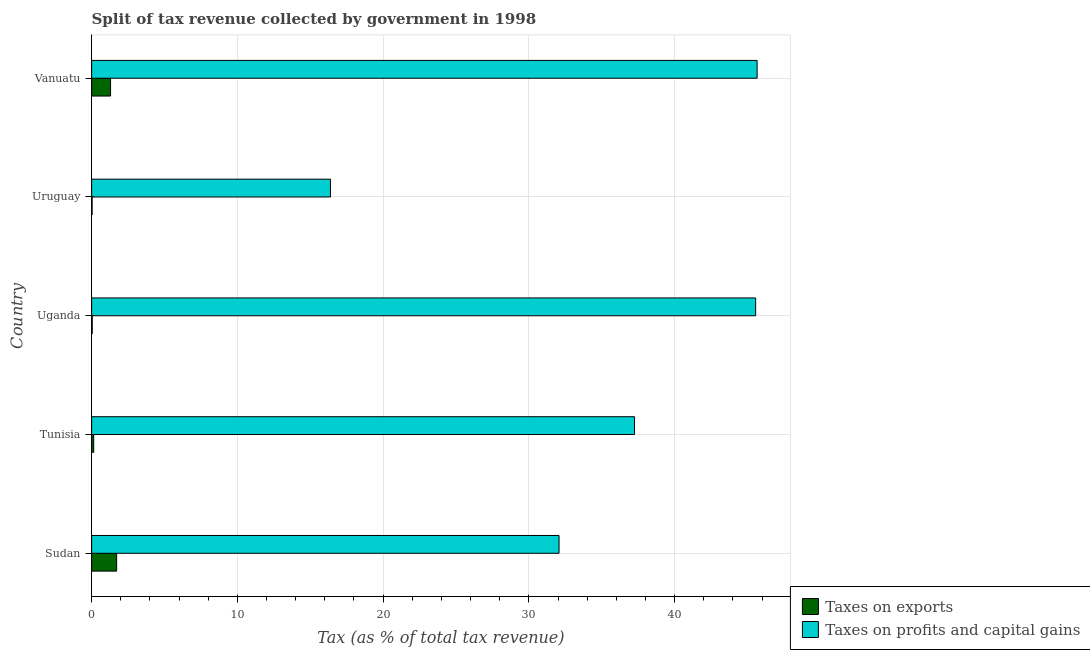How many different coloured bars are there?
Offer a terse response. 2. Are the number of bars per tick equal to the number of legend labels?
Ensure brevity in your answer.  Yes. Are the number of bars on each tick of the Y-axis equal?
Your answer should be compact. Yes. What is the label of the 2nd group of bars from the top?
Your response must be concise. Uruguay. What is the percentage of revenue obtained from taxes on exports in Uganda?
Provide a short and direct response. 0.04. Across all countries, what is the maximum percentage of revenue obtained from taxes on profits and capital gains?
Keep it short and to the point. 45.66. Across all countries, what is the minimum percentage of revenue obtained from taxes on profits and capital gains?
Ensure brevity in your answer.  16.39. In which country was the percentage of revenue obtained from taxes on exports maximum?
Make the answer very short. Sudan. In which country was the percentage of revenue obtained from taxes on exports minimum?
Ensure brevity in your answer.  Uruguay. What is the total percentage of revenue obtained from taxes on profits and capital gains in the graph?
Offer a terse response. 176.92. What is the difference between the percentage of revenue obtained from taxes on exports in Uganda and that in Uruguay?
Your answer should be compact. 0.01. What is the difference between the percentage of revenue obtained from taxes on exports in Uruguay and the percentage of revenue obtained from taxes on profits and capital gains in Tunisia?
Ensure brevity in your answer.  -37.22. What is the average percentage of revenue obtained from taxes on exports per country?
Make the answer very short. 0.65. What is the difference between the percentage of revenue obtained from taxes on profits and capital gains and percentage of revenue obtained from taxes on exports in Uganda?
Your response must be concise. 45.52. In how many countries, is the percentage of revenue obtained from taxes on exports greater than 14 %?
Your answer should be very brief. 0. What is the ratio of the percentage of revenue obtained from taxes on exports in Uganda to that in Vanuatu?
Ensure brevity in your answer.  0.03. Is the percentage of revenue obtained from taxes on exports in Sudan less than that in Uganda?
Keep it short and to the point. No. What is the difference between the highest and the second highest percentage of revenue obtained from taxes on exports?
Provide a succinct answer. 0.42. What is the difference between the highest and the lowest percentage of revenue obtained from taxes on profits and capital gains?
Make the answer very short. 29.27. What does the 2nd bar from the top in Uruguay represents?
Provide a short and direct response. Taxes on exports. What does the 2nd bar from the bottom in Tunisia represents?
Provide a short and direct response. Taxes on profits and capital gains. How many countries are there in the graph?
Offer a very short reply. 5. What is the difference between two consecutive major ticks on the X-axis?
Keep it short and to the point. 10. Are the values on the major ticks of X-axis written in scientific E-notation?
Your answer should be compact. No. Does the graph contain any zero values?
Provide a short and direct response. No. Does the graph contain grids?
Make the answer very short. Yes. How are the legend labels stacked?
Offer a terse response. Vertical. What is the title of the graph?
Offer a terse response. Split of tax revenue collected by government in 1998. Does "Under-5(female)" appear as one of the legend labels in the graph?
Your answer should be very brief. No. What is the label or title of the X-axis?
Your answer should be very brief. Tax (as % of total tax revenue). What is the label or title of the Y-axis?
Offer a terse response. Country. What is the Tax (as % of total tax revenue) in Taxes on exports in Sudan?
Your answer should be compact. 1.72. What is the Tax (as % of total tax revenue) in Taxes on profits and capital gains in Sudan?
Provide a short and direct response. 32.07. What is the Tax (as % of total tax revenue) in Taxes on exports in Tunisia?
Offer a terse response. 0.14. What is the Tax (as % of total tax revenue) of Taxes on profits and capital gains in Tunisia?
Keep it short and to the point. 37.25. What is the Tax (as % of total tax revenue) of Taxes on exports in Uganda?
Give a very brief answer. 0.04. What is the Tax (as % of total tax revenue) in Taxes on profits and capital gains in Uganda?
Your answer should be compact. 45.56. What is the Tax (as % of total tax revenue) of Taxes on exports in Uruguay?
Provide a succinct answer. 0.03. What is the Tax (as % of total tax revenue) of Taxes on profits and capital gains in Uruguay?
Keep it short and to the point. 16.39. What is the Tax (as % of total tax revenue) of Taxes on exports in Vanuatu?
Ensure brevity in your answer.  1.3. What is the Tax (as % of total tax revenue) in Taxes on profits and capital gains in Vanuatu?
Provide a succinct answer. 45.66. Across all countries, what is the maximum Tax (as % of total tax revenue) in Taxes on exports?
Your answer should be compact. 1.72. Across all countries, what is the maximum Tax (as % of total tax revenue) in Taxes on profits and capital gains?
Give a very brief answer. 45.66. Across all countries, what is the minimum Tax (as % of total tax revenue) in Taxes on exports?
Give a very brief answer. 0.03. Across all countries, what is the minimum Tax (as % of total tax revenue) in Taxes on profits and capital gains?
Give a very brief answer. 16.39. What is the total Tax (as % of total tax revenue) of Taxes on exports in the graph?
Keep it short and to the point. 3.22. What is the total Tax (as % of total tax revenue) of Taxes on profits and capital gains in the graph?
Provide a short and direct response. 176.92. What is the difference between the Tax (as % of total tax revenue) of Taxes on exports in Sudan and that in Tunisia?
Keep it short and to the point. 1.57. What is the difference between the Tax (as % of total tax revenue) in Taxes on profits and capital gains in Sudan and that in Tunisia?
Your response must be concise. -5.18. What is the difference between the Tax (as % of total tax revenue) in Taxes on exports in Sudan and that in Uganda?
Your response must be concise. 1.68. What is the difference between the Tax (as % of total tax revenue) in Taxes on profits and capital gains in Sudan and that in Uganda?
Your response must be concise. -13.49. What is the difference between the Tax (as % of total tax revenue) of Taxes on exports in Sudan and that in Uruguay?
Make the answer very short. 1.68. What is the difference between the Tax (as % of total tax revenue) in Taxes on profits and capital gains in Sudan and that in Uruguay?
Provide a succinct answer. 15.68. What is the difference between the Tax (as % of total tax revenue) of Taxes on exports in Sudan and that in Vanuatu?
Your answer should be very brief. 0.42. What is the difference between the Tax (as % of total tax revenue) in Taxes on profits and capital gains in Sudan and that in Vanuatu?
Offer a very short reply. -13.59. What is the difference between the Tax (as % of total tax revenue) in Taxes on exports in Tunisia and that in Uganda?
Give a very brief answer. 0.1. What is the difference between the Tax (as % of total tax revenue) of Taxes on profits and capital gains in Tunisia and that in Uganda?
Provide a short and direct response. -8.31. What is the difference between the Tax (as % of total tax revenue) in Taxes on exports in Tunisia and that in Uruguay?
Provide a short and direct response. 0.11. What is the difference between the Tax (as % of total tax revenue) of Taxes on profits and capital gains in Tunisia and that in Uruguay?
Make the answer very short. 20.86. What is the difference between the Tax (as % of total tax revenue) in Taxes on exports in Tunisia and that in Vanuatu?
Offer a terse response. -1.16. What is the difference between the Tax (as % of total tax revenue) of Taxes on profits and capital gains in Tunisia and that in Vanuatu?
Keep it short and to the point. -8.41. What is the difference between the Tax (as % of total tax revenue) in Taxes on exports in Uganda and that in Uruguay?
Provide a short and direct response. 0.01. What is the difference between the Tax (as % of total tax revenue) in Taxes on profits and capital gains in Uganda and that in Uruguay?
Make the answer very short. 29.17. What is the difference between the Tax (as % of total tax revenue) in Taxes on exports in Uganda and that in Vanuatu?
Ensure brevity in your answer.  -1.26. What is the difference between the Tax (as % of total tax revenue) in Taxes on profits and capital gains in Uganda and that in Vanuatu?
Give a very brief answer. -0.1. What is the difference between the Tax (as % of total tax revenue) in Taxes on exports in Uruguay and that in Vanuatu?
Give a very brief answer. -1.27. What is the difference between the Tax (as % of total tax revenue) in Taxes on profits and capital gains in Uruguay and that in Vanuatu?
Your answer should be very brief. -29.27. What is the difference between the Tax (as % of total tax revenue) of Taxes on exports in Sudan and the Tax (as % of total tax revenue) of Taxes on profits and capital gains in Tunisia?
Offer a very short reply. -35.53. What is the difference between the Tax (as % of total tax revenue) in Taxes on exports in Sudan and the Tax (as % of total tax revenue) in Taxes on profits and capital gains in Uganda?
Your answer should be very brief. -43.84. What is the difference between the Tax (as % of total tax revenue) of Taxes on exports in Sudan and the Tax (as % of total tax revenue) of Taxes on profits and capital gains in Uruguay?
Offer a terse response. -14.67. What is the difference between the Tax (as % of total tax revenue) in Taxes on exports in Sudan and the Tax (as % of total tax revenue) in Taxes on profits and capital gains in Vanuatu?
Provide a succinct answer. -43.94. What is the difference between the Tax (as % of total tax revenue) of Taxes on exports in Tunisia and the Tax (as % of total tax revenue) of Taxes on profits and capital gains in Uganda?
Provide a succinct answer. -45.42. What is the difference between the Tax (as % of total tax revenue) in Taxes on exports in Tunisia and the Tax (as % of total tax revenue) in Taxes on profits and capital gains in Uruguay?
Your answer should be compact. -16.25. What is the difference between the Tax (as % of total tax revenue) in Taxes on exports in Tunisia and the Tax (as % of total tax revenue) in Taxes on profits and capital gains in Vanuatu?
Your answer should be compact. -45.52. What is the difference between the Tax (as % of total tax revenue) in Taxes on exports in Uganda and the Tax (as % of total tax revenue) in Taxes on profits and capital gains in Uruguay?
Make the answer very short. -16.35. What is the difference between the Tax (as % of total tax revenue) of Taxes on exports in Uganda and the Tax (as % of total tax revenue) of Taxes on profits and capital gains in Vanuatu?
Give a very brief answer. -45.62. What is the difference between the Tax (as % of total tax revenue) in Taxes on exports in Uruguay and the Tax (as % of total tax revenue) in Taxes on profits and capital gains in Vanuatu?
Provide a short and direct response. -45.63. What is the average Tax (as % of total tax revenue) of Taxes on exports per country?
Your answer should be very brief. 0.64. What is the average Tax (as % of total tax revenue) of Taxes on profits and capital gains per country?
Make the answer very short. 35.38. What is the difference between the Tax (as % of total tax revenue) of Taxes on exports and Tax (as % of total tax revenue) of Taxes on profits and capital gains in Sudan?
Offer a very short reply. -30.35. What is the difference between the Tax (as % of total tax revenue) of Taxes on exports and Tax (as % of total tax revenue) of Taxes on profits and capital gains in Tunisia?
Your response must be concise. -37.11. What is the difference between the Tax (as % of total tax revenue) in Taxes on exports and Tax (as % of total tax revenue) in Taxes on profits and capital gains in Uganda?
Provide a short and direct response. -45.52. What is the difference between the Tax (as % of total tax revenue) of Taxes on exports and Tax (as % of total tax revenue) of Taxes on profits and capital gains in Uruguay?
Your response must be concise. -16.36. What is the difference between the Tax (as % of total tax revenue) of Taxes on exports and Tax (as % of total tax revenue) of Taxes on profits and capital gains in Vanuatu?
Provide a succinct answer. -44.36. What is the ratio of the Tax (as % of total tax revenue) of Taxes on exports in Sudan to that in Tunisia?
Ensure brevity in your answer.  12.19. What is the ratio of the Tax (as % of total tax revenue) in Taxes on profits and capital gains in Sudan to that in Tunisia?
Give a very brief answer. 0.86. What is the ratio of the Tax (as % of total tax revenue) of Taxes on exports in Sudan to that in Uganda?
Your response must be concise. 43.38. What is the ratio of the Tax (as % of total tax revenue) in Taxes on profits and capital gains in Sudan to that in Uganda?
Keep it short and to the point. 0.7. What is the ratio of the Tax (as % of total tax revenue) in Taxes on exports in Sudan to that in Uruguay?
Keep it short and to the point. 55.31. What is the ratio of the Tax (as % of total tax revenue) in Taxes on profits and capital gains in Sudan to that in Uruguay?
Give a very brief answer. 1.96. What is the ratio of the Tax (as % of total tax revenue) of Taxes on exports in Sudan to that in Vanuatu?
Offer a very short reply. 1.32. What is the ratio of the Tax (as % of total tax revenue) in Taxes on profits and capital gains in Sudan to that in Vanuatu?
Make the answer very short. 0.7. What is the ratio of the Tax (as % of total tax revenue) of Taxes on exports in Tunisia to that in Uganda?
Offer a terse response. 3.56. What is the ratio of the Tax (as % of total tax revenue) in Taxes on profits and capital gains in Tunisia to that in Uganda?
Ensure brevity in your answer.  0.82. What is the ratio of the Tax (as % of total tax revenue) of Taxes on exports in Tunisia to that in Uruguay?
Provide a succinct answer. 4.54. What is the ratio of the Tax (as % of total tax revenue) in Taxes on profits and capital gains in Tunisia to that in Uruguay?
Your answer should be very brief. 2.27. What is the ratio of the Tax (as % of total tax revenue) in Taxes on exports in Tunisia to that in Vanuatu?
Your answer should be compact. 0.11. What is the ratio of the Tax (as % of total tax revenue) of Taxes on profits and capital gains in Tunisia to that in Vanuatu?
Provide a short and direct response. 0.82. What is the ratio of the Tax (as % of total tax revenue) in Taxes on exports in Uganda to that in Uruguay?
Your response must be concise. 1.27. What is the ratio of the Tax (as % of total tax revenue) in Taxes on profits and capital gains in Uganda to that in Uruguay?
Your answer should be very brief. 2.78. What is the ratio of the Tax (as % of total tax revenue) in Taxes on exports in Uganda to that in Vanuatu?
Your answer should be compact. 0.03. What is the ratio of the Tax (as % of total tax revenue) of Taxes on profits and capital gains in Uganda to that in Vanuatu?
Your answer should be compact. 1. What is the ratio of the Tax (as % of total tax revenue) in Taxes on exports in Uruguay to that in Vanuatu?
Offer a terse response. 0.02. What is the ratio of the Tax (as % of total tax revenue) in Taxes on profits and capital gains in Uruguay to that in Vanuatu?
Offer a terse response. 0.36. What is the difference between the highest and the second highest Tax (as % of total tax revenue) of Taxes on exports?
Provide a short and direct response. 0.42. What is the difference between the highest and the second highest Tax (as % of total tax revenue) of Taxes on profits and capital gains?
Make the answer very short. 0.1. What is the difference between the highest and the lowest Tax (as % of total tax revenue) of Taxes on exports?
Offer a very short reply. 1.68. What is the difference between the highest and the lowest Tax (as % of total tax revenue) in Taxes on profits and capital gains?
Make the answer very short. 29.27. 